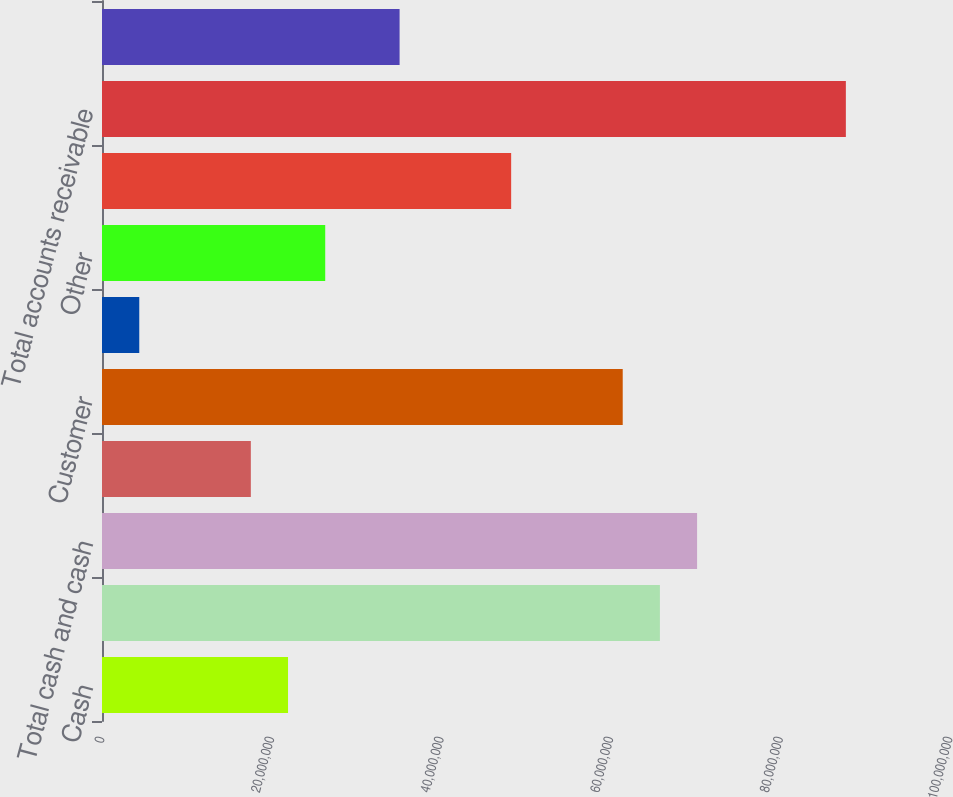<chart> <loc_0><loc_0><loc_500><loc_500><bar_chart><fcel>Cash<fcel>Temporary cash investments<fcel>Total cash and cash<fcel>Securitization recovery trust<fcel>Customer<fcel>Allowance for doubtful<fcel>Other<fcel>Accrued unbilled revenues<fcel>Total accounts receivable<fcel>Deferred fuel costs<nl><fcel>2.19371e+07<fcel>6.57917e+07<fcel>7.01771e+07<fcel>1.75517e+07<fcel>6.14062e+07<fcel>4.39531e+06<fcel>2.63226e+07<fcel>4.82499e+07<fcel>8.7719e+07<fcel>3.50935e+07<nl></chart> 